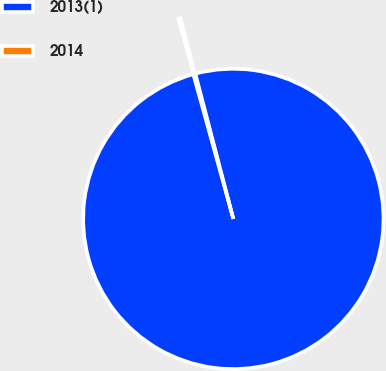Convert chart. <chart><loc_0><loc_0><loc_500><loc_500><pie_chart><fcel>2013(1)<fcel>2014<nl><fcel>99.78%<fcel>0.22%<nl></chart> 